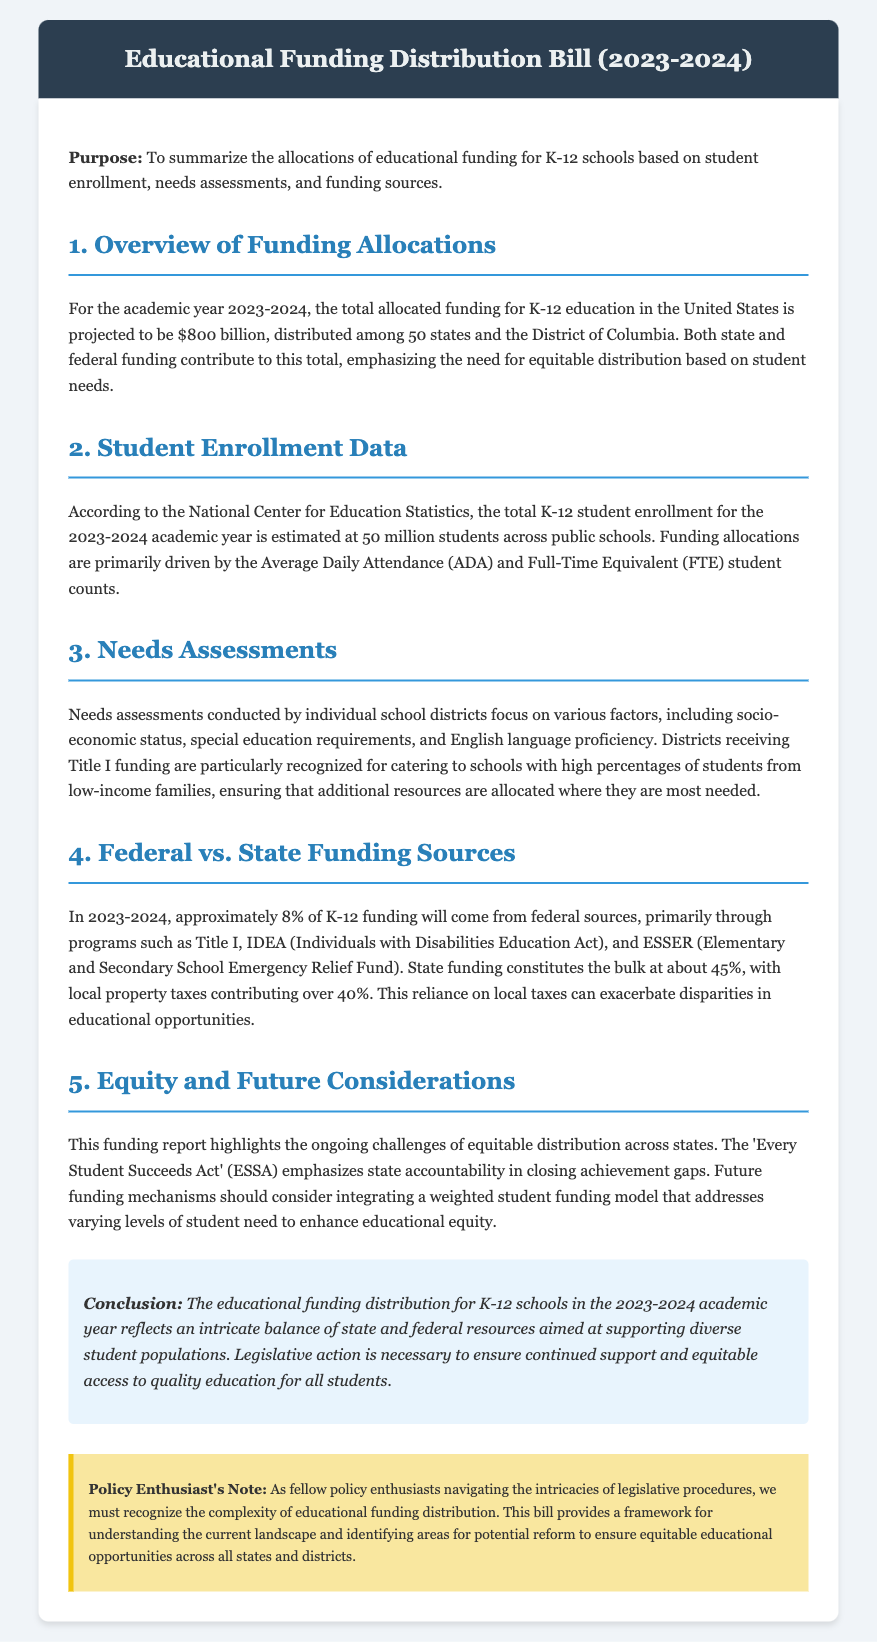what is the total allocated funding for K-12 education in 2023-2024? The total allocated funding for K-12 education is projected to be $800 billion based on the information in the document.
Answer: $800 billion how many students are estimated for K-12 enrollment in 2023-2024? According to the National Center for Education Statistics, the total K-12 student enrollment is estimated at 50 million students.
Answer: 50 million what percentage of K-12 funding will come from federal sources? The document states that approximately 8% of K-12 funding will come from federal sources.
Answer: 8% which act emphasizes state accountability in closing achievement gaps? The document references 'Every Student Succeeds Act' (ESSA) concerning state accountability in educational equity.
Answer: Every Student Succeeds Act what factors are considered in needs assessments by school districts? The needs assessments focus on socio-economic status, special education requirements, and English language proficiency.
Answer: socio-economic status, special education requirements, and English language proficiency what is the primary source of state funding for K-12 education? The primary source of state funding for K-12 education is local property taxes, as indicated in the document.
Answer: local property taxes how does funding relate to socio-economic status? The document implies that districts receiving Title I funding cater to schools with high percentages of students from low-income families, which addresses socio-economic disparities.
Answer: high percentages of students from low-income families what is emphasized for future funding mechanisms to enhance educational equity? The document suggests integrating a weighted student funding model to address varying levels of student need.
Answer: weighted student funding model 